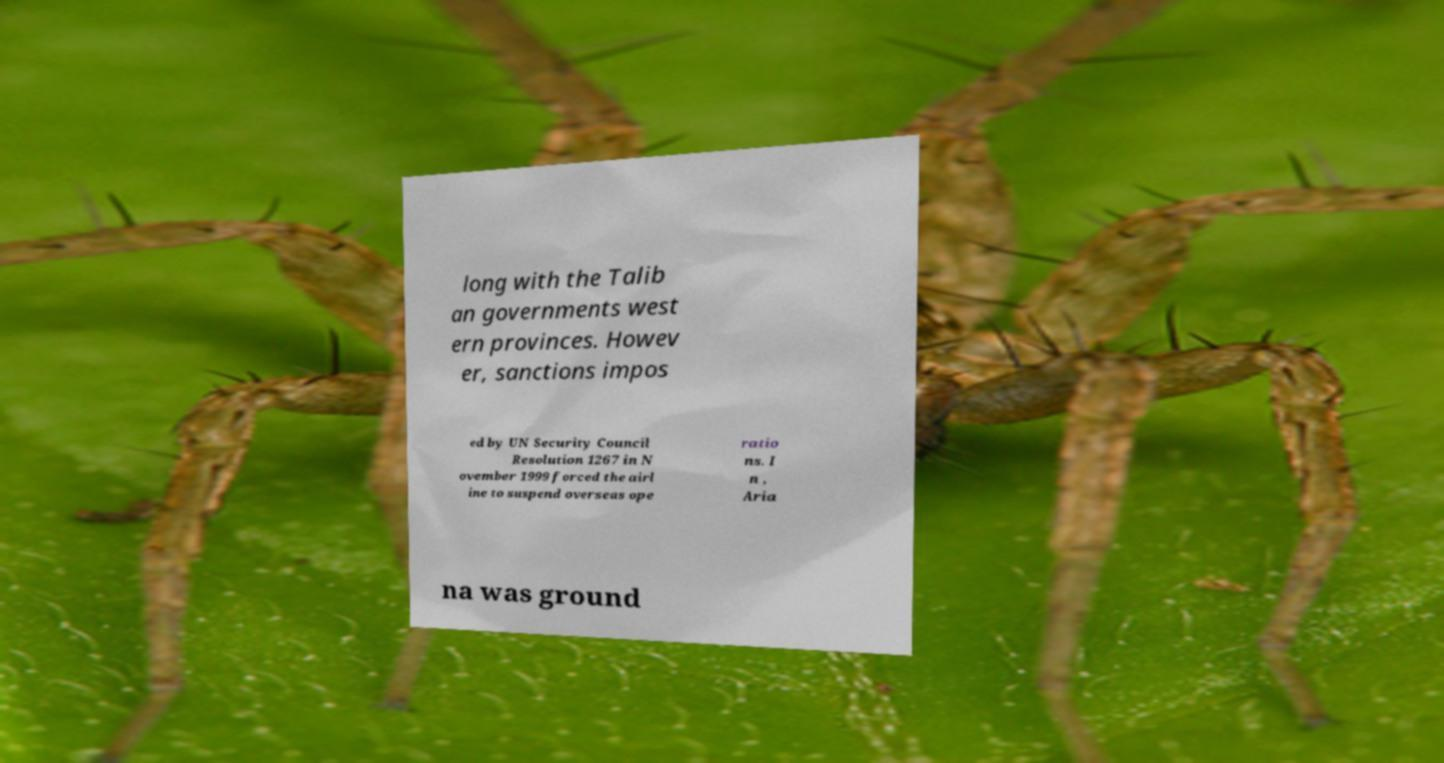Could you extract and type out the text from this image? long with the Talib an governments west ern provinces. Howev er, sanctions impos ed by UN Security Council Resolution 1267 in N ovember 1999 forced the airl ine to suspend overseas ope ratio ns. I n , Aria na was ground 